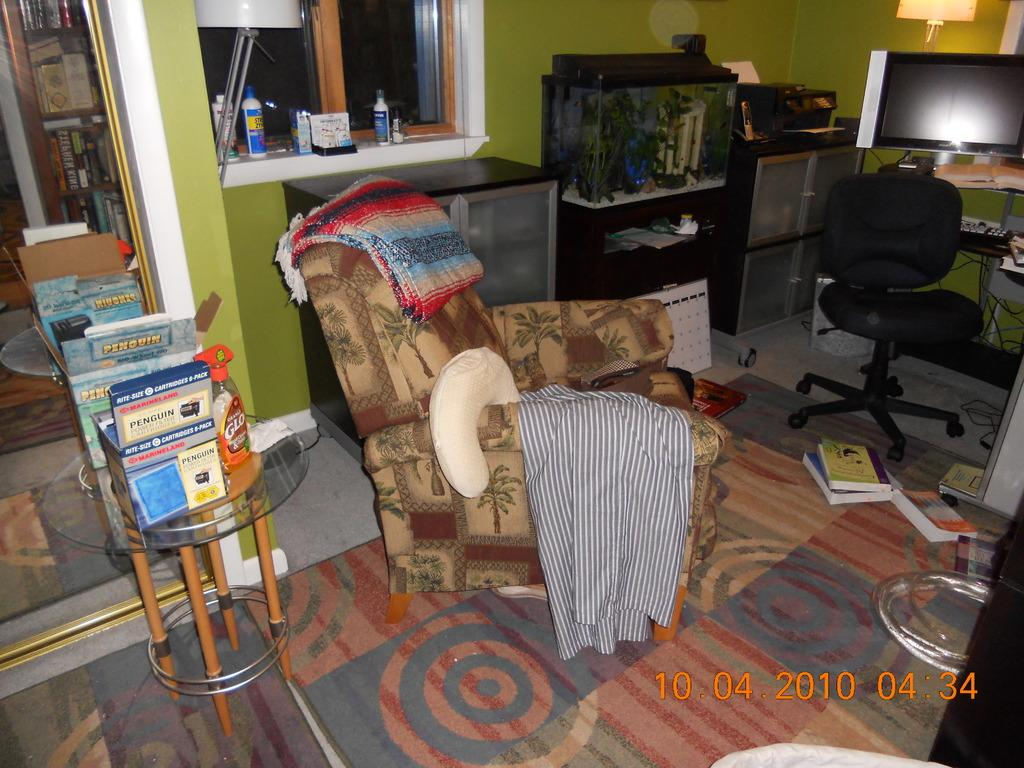<image>
Offer a succinct explanation of the picture presented. A photo of a rocking chair in a living room was taken on October 4 ,2010. 